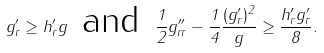Convert formula to latex. <formula><loc_0><loc_0><loc_500><loc_500>g ^ { \prime } _ { r } \geq h ^ { \prime } _ { r } g \, \text { and } \, \frac { 1 } { 2 } g ^ { \prime \prime } _ { r r } - \frac { 1 } { 4 } \frac { ( g ^ { \prime } _ { r } ) ^ { 2 } } { g } \geq \frac { h ^ { \prime } _ { r } g ^ { \prime } _ { r } } { 8 } .</formula> 